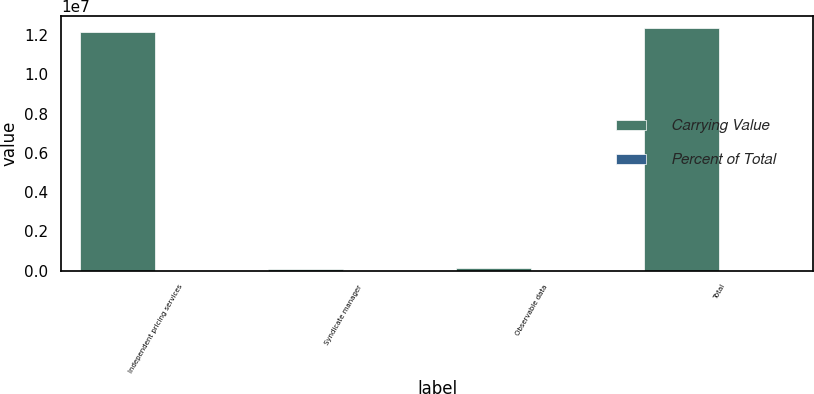Convert chart. <chart><loc_0><loc_0><loc_500><loc_500><stacked_bar_chart><ecel><fcel>Independent pricing services<fcel>Syndicate manager<fcel>Observable data<fcel>Total<nl><fcel>Carrying Value<fcel>1.21328e+07<fcel>64758<fcel>150187<fcel>1.23481e+07<nl><fcel>Percent of Total<fcel>98.3<fcel>0.5<fcel>1.2<fcel>100<nl></chart> 